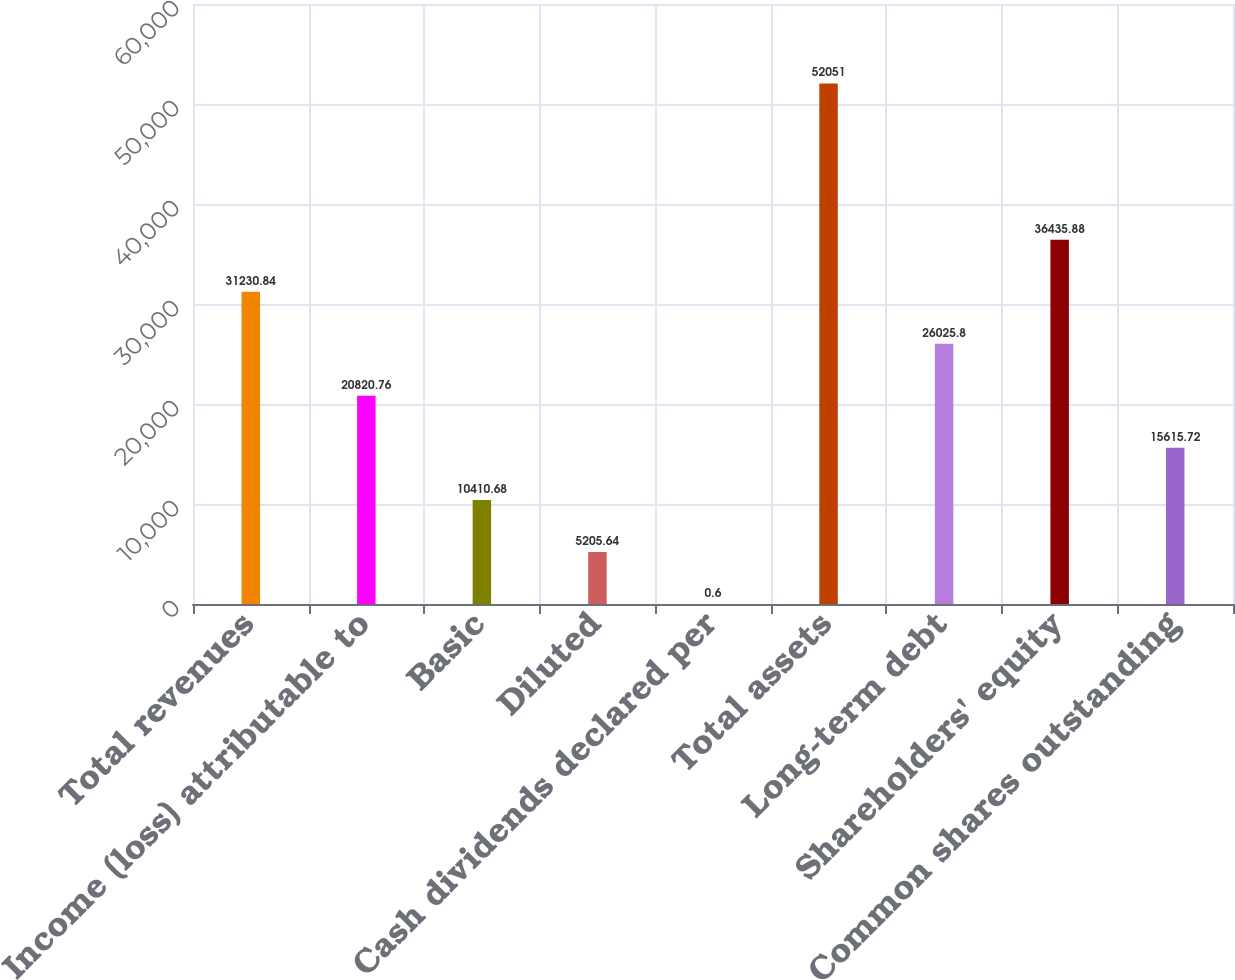<chart> <loc_0><loc_0><loc_500><loc_500><bar_chart><fcel>Total revenues<fcel>Income (loss) attributable to<fcel>Basic<fcel>Diluted<fcel>Cash dividends declared per<fcel>Total assets<fcel>Long-term debt<fcel>Shareholders' equity<fcel>Common shares outstanding<nl><fcel>31230.8<fcel>20820.8<fcel>10410.7<fcel>5205.64<fcel>0.6<fcel>52051<fcel>26025.8<fcel>36435.9<fcel>15615.7<nl></chart> 